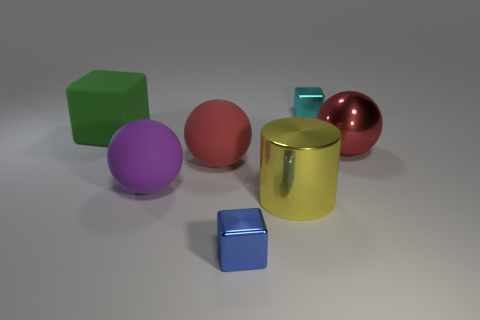Add 2 large green objects. How many objects exist? 9 Subtract all blocks. How many objects are left? 4 Add 7 small cyan shiny blocks. How many small cyan shiny blocks exist? 8 Subtract 0 brown blocks. How many objects are left? 7 Subtract all large cylinders. Subtract all large gray shiny balls. How many objects are left? 6 Add 5 red metallic objects. How many red metallic objects are left? 6 